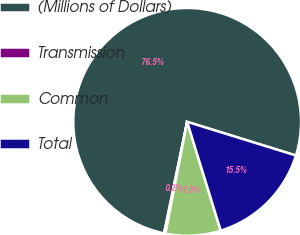Convert chart. <chart><loc_0><loc_0><loc_500><loc_500><pie_chart><fcel>(Millions of Dollars)<fcel>Transmission<fcel>Common<fcel>Total<nl><fcel>76.53%<fcel>0.19%<fcel>7.82%<fcel>15.46%<nl></chart> 